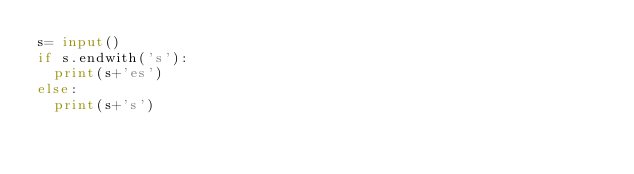<code> <loc_0><loc_0><loc_500><loc_500><_Python_>s= input()
if s.endwith('s'):
  print(s+'es')
else:
  print(s+'s')</code> 